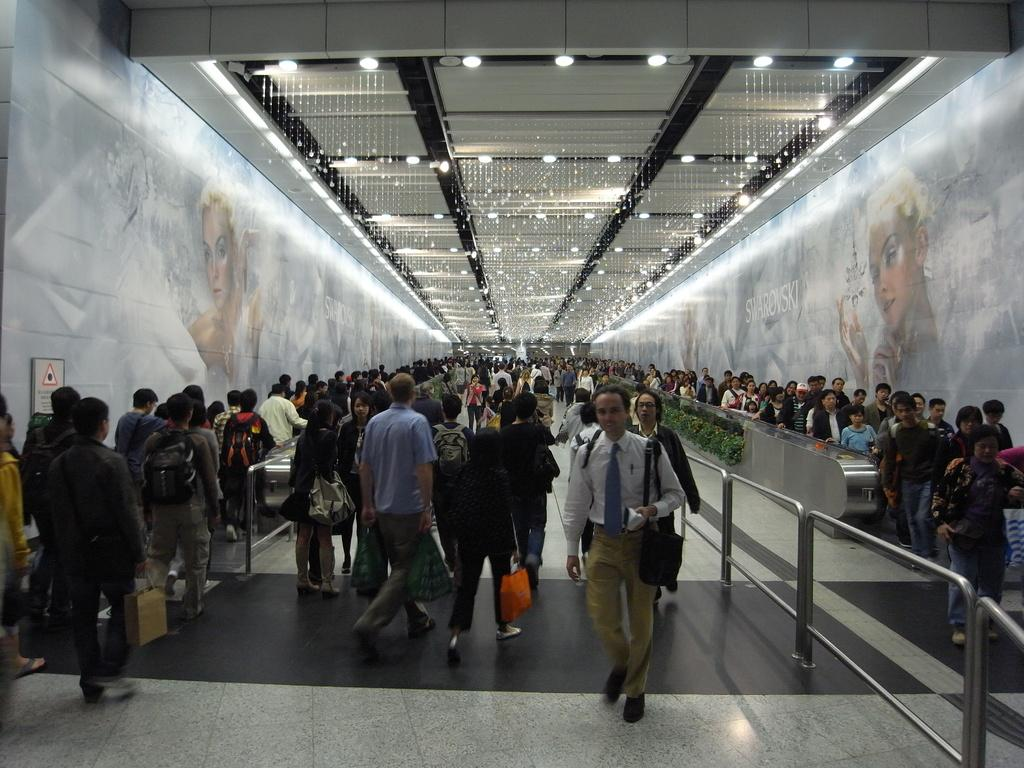How many people are in the image? There is a group of people in the image. What are the people in the image doing? The people are walking on the floor. What can be seen on the wall in the image? There is a wallboard in the image. What type of vegetation is present in the image? There are plants in the image. What is above the people in the image? There is a roof in the image. What is used to provide light in the image? Ceiling lights are present in the image. Can you see any rifles being used by the people in the image? There are no rifles present in the image. What type of beast can be seen interacting with the plants in the image? There are no beasts present in the image; only people, plants, and other objects can be seen. 